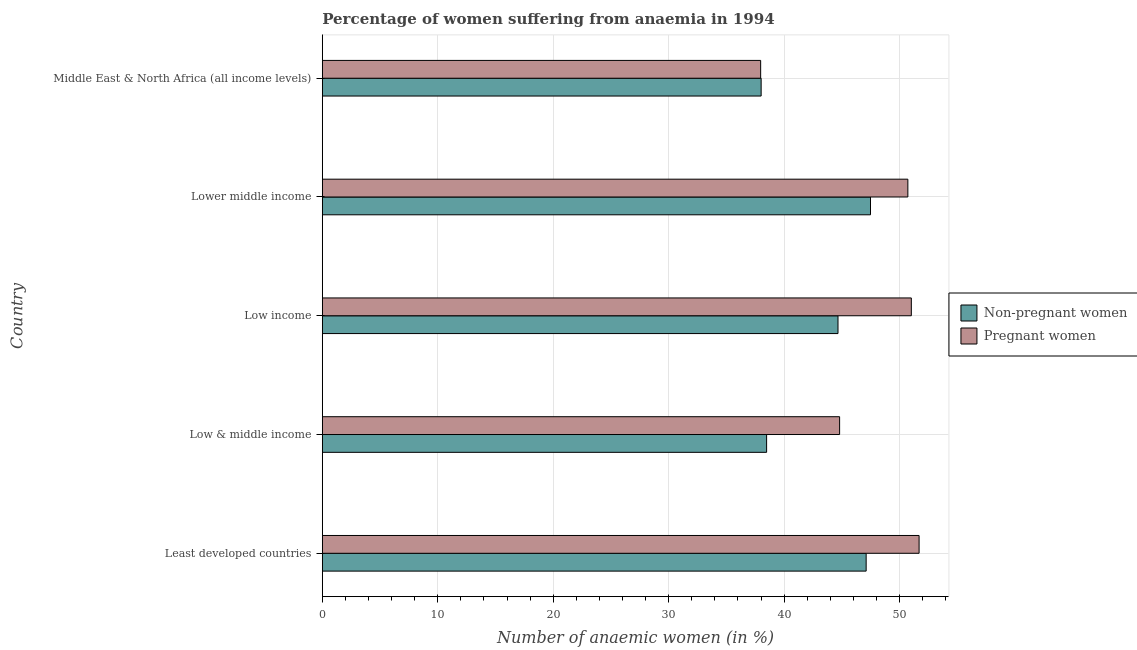How many different coloured bars are there?
Your answer should be very brief. 2. Are the number of bars per tick equal to the number of legend labels?
Offer a very short reply. Yes. Are the number of bars on each tick of the Y-axis equal?
Ensure brevity in your answer.  Yes. How many bars are there on the 4th tick from the bottom?
Your response must be concise. 2. What is the label of the 1st group of bars from the top?
Provide a short and direct response. Middle East & North Africa (all income levels). In how many cases, is the number of bars for a given country not equal to the number of legend labels?
Make the answer very short. 0. What is the percentage of pregnant anaemic women in Low & middle income?
Offer a very short reply. 44.8. Across all countries, what is the maximum percentage of pregnant anaemic women?
Your answer should be very brief. 51.69. Across all countries, what is the minimum percentage of non-pregnant anaemic women?
Your answer should be very brief. 38.01. In which country was the percentage of non-pregnant anaemic women maximum?
Give a very brief answer. Lower middle income. In which country was the percentage of non-pregnant anaemic women minimum?
Offer a very short reply. Middle East & North Africa (all income levels). What is the total percentage of non-pregnant anaemic women in the graph?
Make the answer very short. 215.74. What is the difference between the percentage of non-pregnant anaemic women in Low income and that in Lower middle income?
Provide a succinct answer. -2.81. What is the difference between the percentage of non-pregnant anaemic women in Middle East & North Africa (all income levels) and the percentage of pregnant anaemic women in Lower middle income?
Make the answer very short. -12.71. What is the average percentage of non-pregnant anaemic women per country?
Your answer should be compact. 43.15. What is the difference between the percentage of pregnant anaemic women and percentage of non-pregnant anaemic women in Middle East & North Africa (all income levels)?
Keep it short and to the point. -0.04. What is the ratio of the percentage of non-pregnant anaemic women in Least developed countries to that in Low & middle income?
Ensure brevity in your answer.  1.22. Is the difference between the percentage of non-pregnant anaemic women in Least developed countries and Lower middle income greater than the difference between the percentage of pregnant anaemic women in Least developed countries and Lower middle income?
Offer a very short reply. No. What is the difference between the highest and the second highest percentage of pregnant anaemic women?
Make the answer very short. 0.67. What is the difference between the highest and the lowest percentage of pregnant anaemic women?
Offer a terse response. 13.72. In how many countries, is the percentage of non-pregnant anaemic women greater than the average percentage of non-pregnant anaemic women taken over all countries?
Provide a short and direct response. 3. What does the 1st bar from the top in Middle East & North Africa (all income levels) represents?
Make the answer very short. Pregnant women. What does the 2nd bar from the bottom in Low income represents?
Offer a very short reply. Pregnant women. Are all the bars in the graph horizontal?
Keep it short and to the point. Yes. How many countries are there in the graph?
Provide a short and direct response. 5. What is the difference between two consecutive major ticks on the X-axis?
Offer a terse response. 10. Does the graph contain any zero values?
Offer a very short reply. No. Does the graph contain grids?
Offer a very short reply. Yes. How are the legend labels stacked?
Your answer should be very brief. Vertical. What is the title of the graph?
Your answer should be very brief. Percentage of women suffering from anaemia in 1994. Does "Under-5(male)" appear as one of the legend labels in the graph?
Make the answer very short. No. What is the label or title of the X-axis?
Give a very brief answer. Number of anaemic women (in %). What is the label or title of the Y-axis?
Your answer should be compact. Country. What is the Number of anaemic women (in %) of Non-pregnant women in Least developed countries?
Your answer should be compact. 47.1. What is the Number of anaemic women (in %) of Pregnant women in Least developed countries?
Offer a terse response. 51.69. What is the Number of anaemic women (in %) in Non-pregnant women in Low & middle income?
Ensure brevity in your answer.  38.48. What is the Number of anaemic women (in %) of Pregnant women in Low & middle income?
Your answer should be very brief. 44.8. What is the Number of anaemic women (in %) of Non-pregnant women in Low income?
Keep it short and to the point. 44.67. What is the Number of anaemic women (in %) of Pregnant women in Low income?
Offer a terse response. 51.02. What is the Number of anaemic women (in %) in Non-pregnant women in Lower middle income?
Your answer should be compact. 47.48. What is the Number of anaemic women (in %) of Pregnant women in Lower middle income?
Ensure brevity in your answer.  50.72. What is the Number of anaemic women (in %) of Non-pregnant women in Middle East & North Africa (all income levels)?
Your response must be concise. 38.01. What is the Number of anaemic women (in %) in Pregnant women in Middle East & North Africa (all income levels)?
Ensure brevity in your answer.  37.97. Across all countries, what is the maximum Number of anaemic women (in %) of Non-pregnant women?
Offer a very short reply. 47.48. Across all countries, what is the maximum Number of anaemic women (in %) of Pregnant women?
Provide a short and direct response. 51.69. Across all countries, what is the minimum Number of anaemic women (in %) in Non-pregnant women?
Make the answer very short. 38.01. Across all countries, what is the minimum Number of anaemic women (in %) of Pregnant women?
Offer a very short reply. 37.97. What is the total Number of anaemic women (in %) of Non-pregnant women in the graph?
Make the answer very short. 215.74. What is the total Number of anaemic women (in %) of Pregnant women in the graph?
Provide a succinct answer. 236.2. What is the difference between the Number of anaemic women (in %) in Non-pregnant women in Least developed countries and that in Low & middle income?
Offer a terse response. 8.62. What is the difference between the Number of anaemic women (in %) in Pregnant women in Least developed countries and that in Low & middle income?
Ensure brevity in your answer.  6.88. What is the difference between the Number of anaemic women (in %) in Non-pregnant women in Least developed countries and that in Low income?
Offer a very short reply. 2.44. What is the difference between the Number of anaemic women (in %) of Pregnant women in Least developed countries and that in Low income?
Offer a terse response. 0.67. What is the difference between the Number of anaemic women (in %) of Non-pregnant women in Least developed countries and that in Lower middle income?
Ensure brevity in your answer.  -0.38. What is the difference between the Number of anaemic women (in %) in Pregnant women in Least developed countries and that in Lower middle income?
Provide a short and direct response. 0.97. What is the difference between the Number of anaemic women (in %) in Non-pregnant women in Least developed countries and that in Middle East & North Africa (all income levels)?
Provide a short and direct response. 9.1. What is the difference between the Number of anaemic women (in %) in Pregnant women in Least developed countries and that in Middle East & North Africa (all income levels)?
Ensure brevity in your answer.  13.72. What is the difference between the Number of anaemic women (in %) of Non-pregnant women in Low & middle income and that in Low income?
Keep it short and to the point. -6.18. What is the difference between the Number of anaemic women (in %) of Pregnant women in Low & middle income and that in Low income?
Provide a short and direct response. -6.21. What is the difference between the Number of anaemic women (in %) in Non-pregnant women in Low & middle income and that in Lower middle income?
Your answer should be very brief. -9. What is the difference between the Number of anaemic women (in %) of Pregnant women in Low & middle income and that in Lower middle income?
Ensure brevity in your answer.  -5.91. What is the difference between the Number of anaemic women (in %) in Non-pregnant women in Low & middle income and that in Middle East & North Africa (all income levels)?
Keep it short and to the point. 0.47. What is the difference between the Number of anaemic women (in %) of Pregnant women in Low & middle income and that in Middle East & North Africa (all income levels)?
Your answer should be compact. 6.84. What is the difference between the Number of anaemic women (in %) of Non-pregnant women in Low income and that in Lower middle income?
Your answer should be very brief. -2.81. What is the difference between the Number of anaemic women (in %) in Pregnant women in Low income and that in Lower middle income?
Provide a succinct answer. 0.3. What is the difference between the Number of anaemic women (in %) of Non-pregnant women in Low income and that in Middle East & North Africa (all income levels)?
Your answer should be compact. 6.66. What is the difference between the Number of anaemic women (in %) in Pregnant women in Low income and that in Middle East & North Africa (all income levels)?
Offer a terse response. 13.05. What is the difference between the Number of anaemic women (in %) of Non-pregnant women in Lower middle income and that in Middle East & North Africa (all income levels)?
Make the answer very short. 9.47. What is the difference between the Number of anaemic women (in %) of Pregnant women in Lower middle income and that in Middle East & North Africa (all income levels)?
Offer a very short reply. 12.75. What is the difference between the Number of anaemic women (in %) of Non-pregnant women in Least developed countries and the Number of anaemic women (in %) of Pregnant women in Low & middle income?
Offer a very short reply. 2.3. What is the difference between the Number of anaemic women (in %) of Non-pregnant women in Least developed countries and the Number of anaemic women (in %) of Pregnant women in Low income?
Ensure brevity in your answer.  -3.91. What is the difference between the Number of anaemic women (in %) of Non-pregnant women in Least developed countries and the Number of anaemic women (in %) of Pregnant women in Lower middle income?
Offer a very short reply. -3.61. What is the difference between the Number of anaemic women (in %) of Non-pregnant women in Least developed countries and the Number of anaemic women (in %) of Pregnant women in Middle East & North Africa (all income levels)?
Give a very brief answer. 9.14. What is the difference between the Number of anaemic women (in %) in Non-pregnant women in Low & middle income and the Number of anaemic women (in %) in Pregnant women in Low income?
Offer a terse response. -12.54. What is the difference between the Number of anaemic women (in %) in Non-pregnant women in Low & middle income and the Number of anaemic women (in %) in Pregnant women in Lower middle income?
Ensure brevity in your answer.  -12.23. What is the difference between the Number of anaemic women (in %) of Non-pregnant women in Low & middle income and the Number of anaemic women (in %) of Pregnant women in Middle East & North Africa (all income levels)?
Give a very brief answer. 0.52. What is the difference between the Number of anaemic women (in %) in Non-pregnant women in Low income and the Number of anaemic women (in %) in Pregnant women in Lower middle income?
Your answer should be very brief. -6.05. What is the difference between the Number of anaemic women (in %) in Non-pregnant women in Low income and the Number of anaemic women (in %) in Pregnant women in Middle East & North Africa (all income levels)?
Make the answer very short. 6.7. What is the difference between the Number of anaemic women (in %) of Non-pregnant women in Lower middle income and the Number of anaemic women (in %) of Pregnant women in Middle East & North Africa (all income levels)?
Offer a very short reply. 9.51. What is the average Number of anaemic women (in %) in Non-pregnant women per country?
Keep it short and to the point. 43.15. What is the average Number of anaemic women (in %) in Pregnant women per country?
Make the answer very short. 47.24. What is the difference between the Number of anaemic women (in %) of Non-pregnant women and Number of anaemic women (in %) of Pregnant women in Least developed countries?
Give a very brief answer. -4.59. What is the difference between the Number of anaemic women (in %) in Non-pregnant women and Number of anaemic women (in %) in Pregnant women in Low & middle income?
Your answer should be compact. -6.32. What is the difference between the Number of anaemic women (in %) of Non-pregnant women and Number of anaemic women (in %) of Pregnant women in Low income?
Give a very brief answer. -6.35. What is the difference between the Number of anaemic women (in %) in Non-pregnant women and Number of anaemic women (in %) in Pregnant women in Lower middle income?
Your answer should be compact. -3.24. What is the difference between the Number of anaemic women (in %) of Non-pregnant women and Number of anaemic women (in %) of Pregnant women in Middle East & North Africa (all income levels)?
Provide a short and direct response. 0.04. What is the ratio of the Number of anaemic women (in %) of Non-pregnant women in Least developed countries to that in Low & middle income?
Keep it short and to the point. 1.22. What is the ratio of the Number of anaemic women (in %) of Pregnant women in Least developed countries to that in Low & middle income?
Provide a succinct answer. 1.15. What is the ratio of the Number of anaemic women (in %) in Non-pregnant women in Least developed countries to that in Low income?
Give a very brief answer. 1.05. What is the ratio of the Number of anaemic women (in %) in Pregnant women in Least developed countries to that in Low income?
Offer a very short reply. 1.01. What is the ratio of the Number of anaemic women (in %) of Non-pregnant women in Least developed countries to that in Lower middle income?
Provide a short and direct response. 0.99. What is the ratio of the Number of anaemic women (in %) in Pregnant women in Least developed countries to that in Lower middle income?
Offer a terse response. 1.02. What is the ratio of the Number of anaemic women (in %) in Non-pregnant women in Least developed countries to that in Middle East & North Africa (all income levels)?
Your response must be concise. 1.24. What is the ratio of the Number of anaemic women (in %) of Pregnant women in Least developed countries to that in Middle East & North Africa (all income levels)?
Your answer should be compact. 1.36. What is the ratio of the Number of anaemic women (in %) in Non-pregnant women in Low & middle income to that in Low income?
Ensure brevity in your answer.  0.86. What is the ratio of the Number of anaemic women (in %) in Pregnant women in Low & middle income to that in Low income?
Ensure brevity in your answer.  0.88. What is the ratio of the Number of anaemic women (in %) in Non-pregnant women in Low & middle income to that in Lower middle income?
Keep it short and to the point. 0.81. What is the ratio of the Number of anaemic women (in %) of Pregnant women in Low & middle income to that in Lower middle income?
Offer a very short reply. 0.88. What is the ratio of the Number of anaemic women (in %) of Non-pregnant women in Low & middle income to that in Middle East & North Africa (all income levels)?
Make the answer very short. 1.01. What is the ratio of the Number of anaemic women (in %) of Pregnant women in Low & middle income to that in Middle East & North Africa (all income levels)?
Offer a terse response. 1.18. What is the ratio of the Number of anaemic women (in %) of Non-pregnant women in Low income to that in Lower middle income?
Give a very brief answer. 0.94. What is the ratio of the Number of anaemic women (in %) of Pregnant women in Low income to that in Lower middle income?
Make the answer very short. 1.01. What is the ratio of the Number of anaemic women (in %) of Non-pregnant women in Low income to that in Middle East & North Africa (all income levels)?
Offer a terse response. 1.18. What is the ratio of the Number of anaemic women (in %) of Pregnant women in Low income to that in Middle East & North Africa (all income levels)?
Give a very brief answer. 1.34. What is the ratio of the Number of anaemic women (in %) of Non-pregnant women in Lower middle income to that in Middle East & North Africa (all income levels)?
Your answer should be compact. 1.25. What is the ratio of the Number of anaemic women (in %) of Pregnant women in Lower middle income to that in Middle East & North Africa (all income levels)?
Keep it short and to the point. 1.34. What is the difference between the highest and the second highest Number of anaemic women (in %) of Non-pregnant women?
Keep it short and to the point. 0.38. What is the difference between the highest and the second highest Number of anaemic women (in %) of Pregnant women?
Your answer should be compact. 0.67. What is the difference between the highest and the lowest Number of anaemic women (in %) in Non-pregnant women?
Offer a very short reply. 9.47. What is the difference between the highest and the lowest Number of anaemic women (in %) of Pregnant women?
Your answer should be compact. 13.72. 